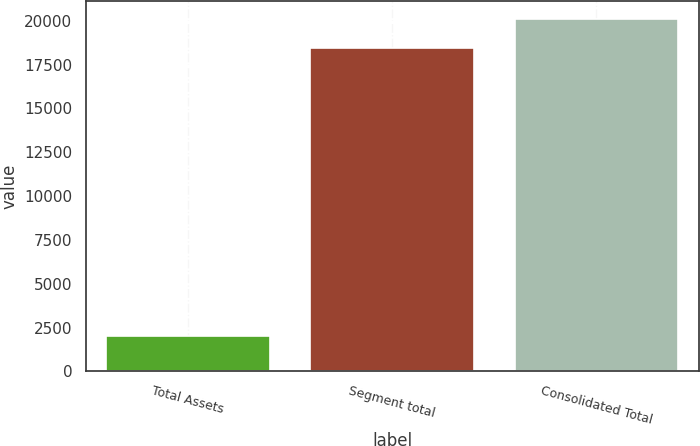Convert chart to OTSL. <chart><loc_0><loc_0><loc_500><loc_500><bar_chart><fcel>Total Assets<fcel>Segment total<fcel>Consolidated Total<nl><fcel>2017<fcel>18457<fcel>20102<nl></chart> 